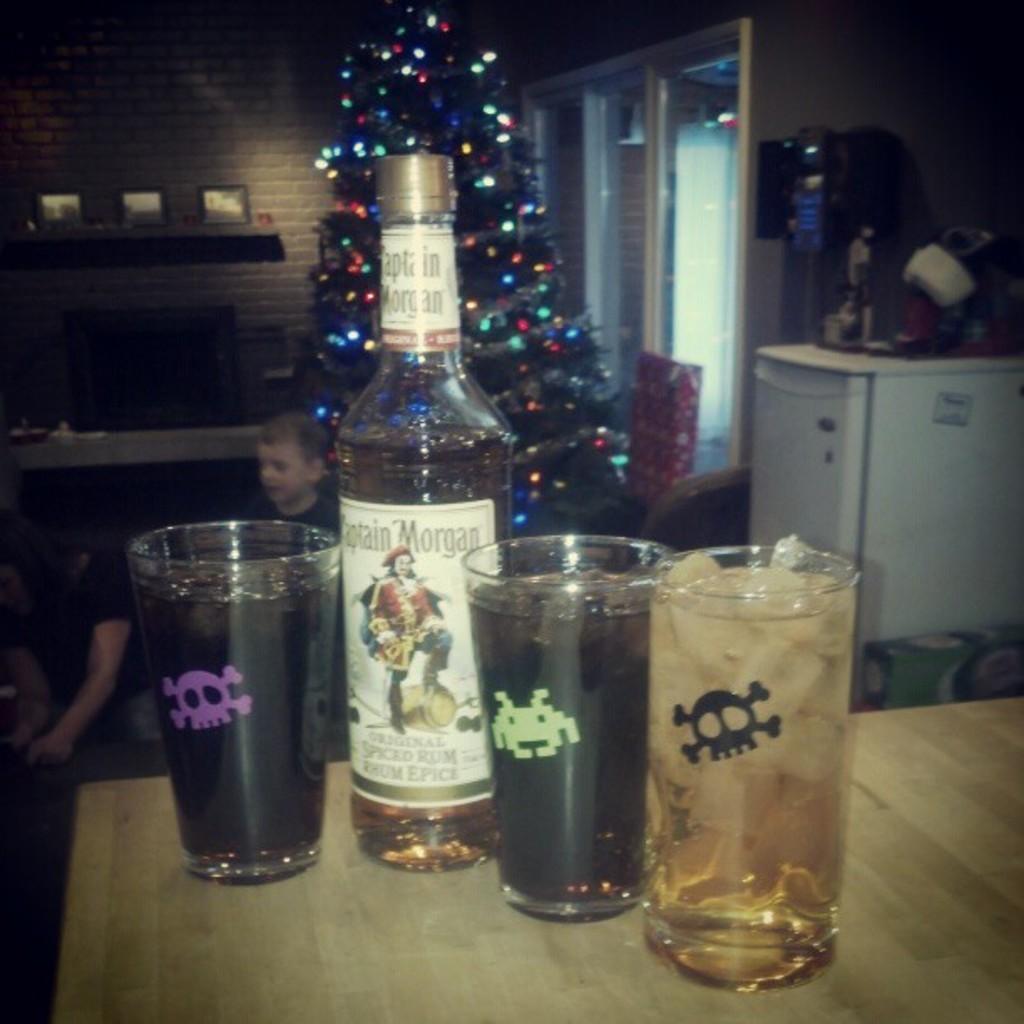What is the brand of alcohol in the picture?
Offer a very short reply. Captain morgan. What kind of alcohol is that?
Your answer should be compact. Spiced rum. 